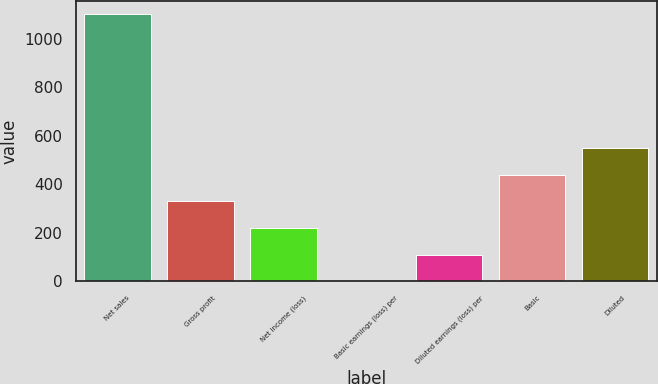Convert chart to OTSL. <chart><loc_0><loc_0><loc_500><loc_500><bar_chart><fcel>Net sales<fcel>Gross profit<fcel>Net income (loss)<fcel>Basic earnings (loss) per<fcel>Diluted earnings (loss) per<fcel>Basic<fcel>Diluted<nl><fcel>1100<fcel>330.08<fcel>220.09<fcel>0.11<fcel>110.1<fcel>440.07<fcel>550.06<nl></chart> 